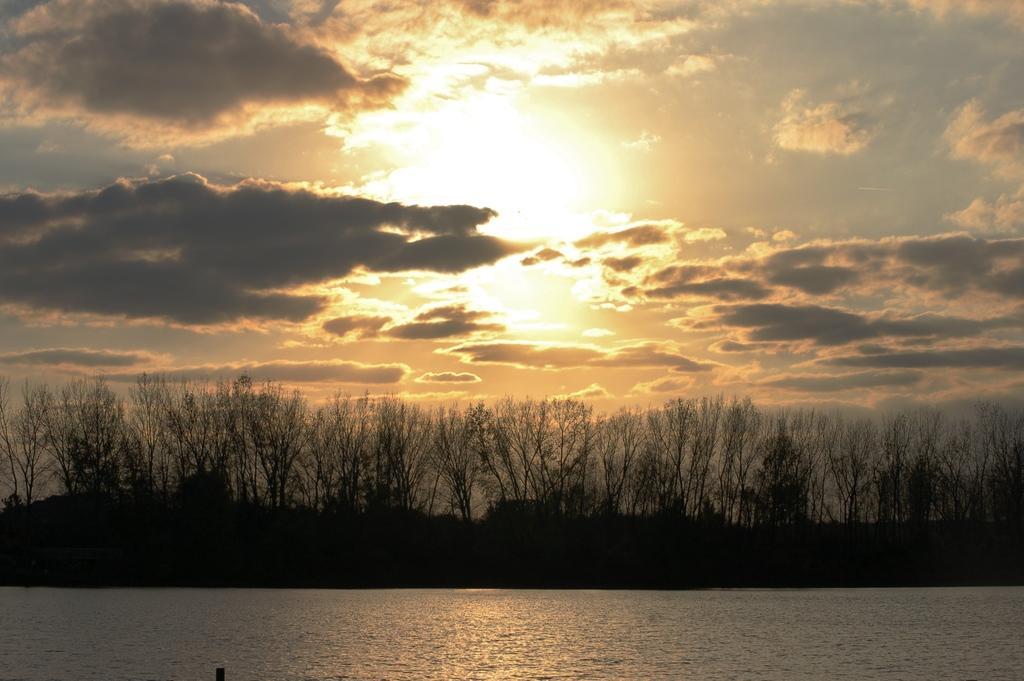Could you give a brief overview of what you see in this image? In this image in the front there is water. In the background there are trees and the sky is cloudy. 